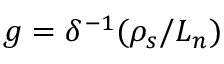<formula> <loc_0><loc_0><loc_500><loc_500>g = \delta ^ { - 1 } ( \rho _ { s } / L _ { n } )</formula> 